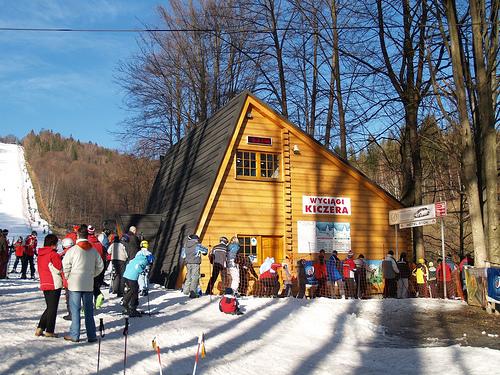Are shadows cast?
Quick response, please. Yes. Is the sign on the building written in Polish?
Concise answer only. Yes. What is the brown building behind the people used for?
Answer briefly. Eating. 